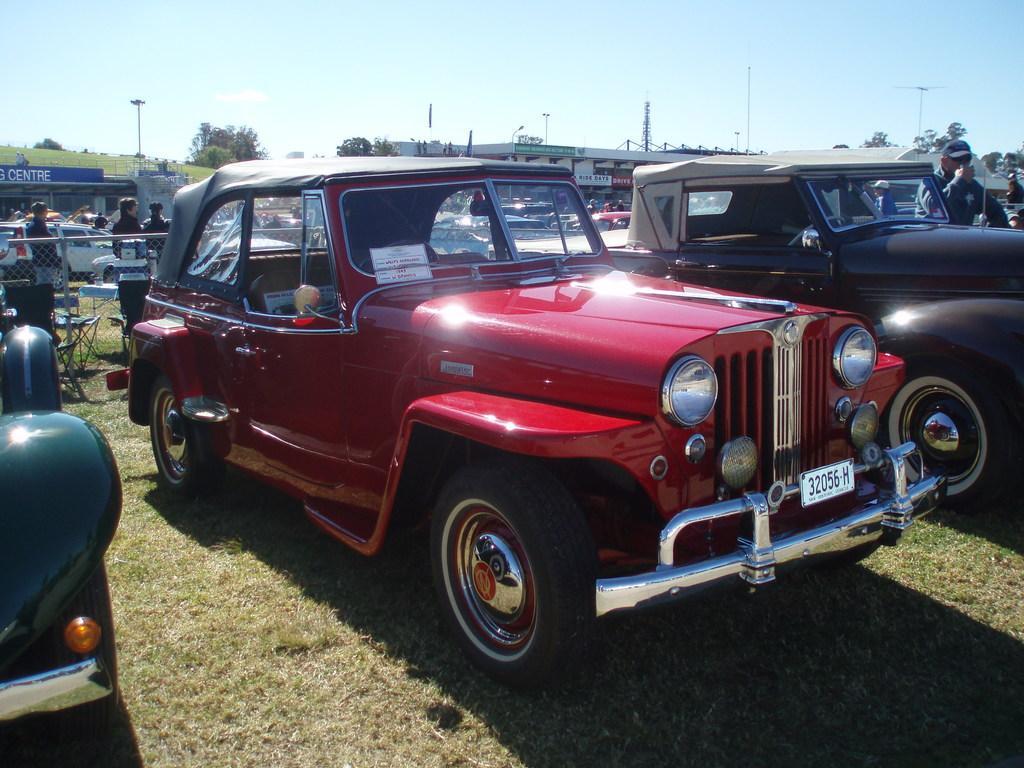How would you summarize this image in a sentence or two? In this image we can see motor vehicles on the ground, persons standing on the ground, fence, buildings, name boards, towers, trees and sky. 